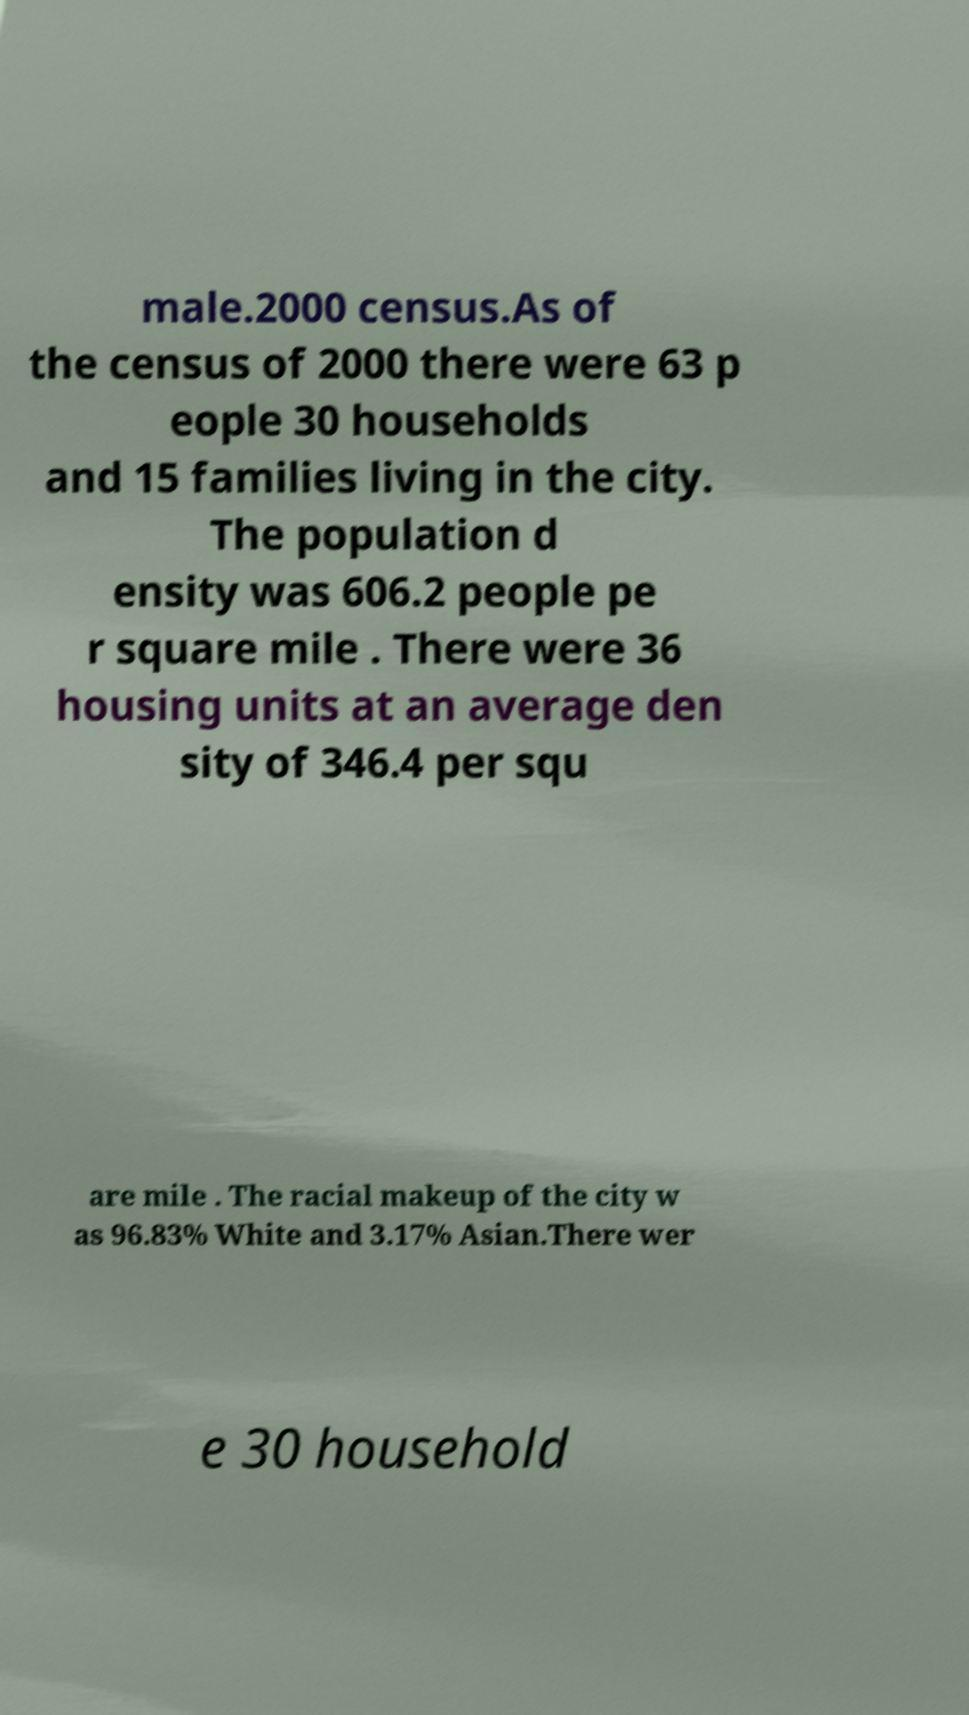Please read and relay the text visible in this image. What does it say? male.2000 census.As of the census of 2000 there were 63 p eople 30 households and 15 families living in the city. The population d ensity was 606.2 people pe r square mile . There were 36 housing units at an average den sity of 346.4 per squ are mile . The racial makeup of the city w as 96.83% White and 3.17% Asian.There wer e 30 household 